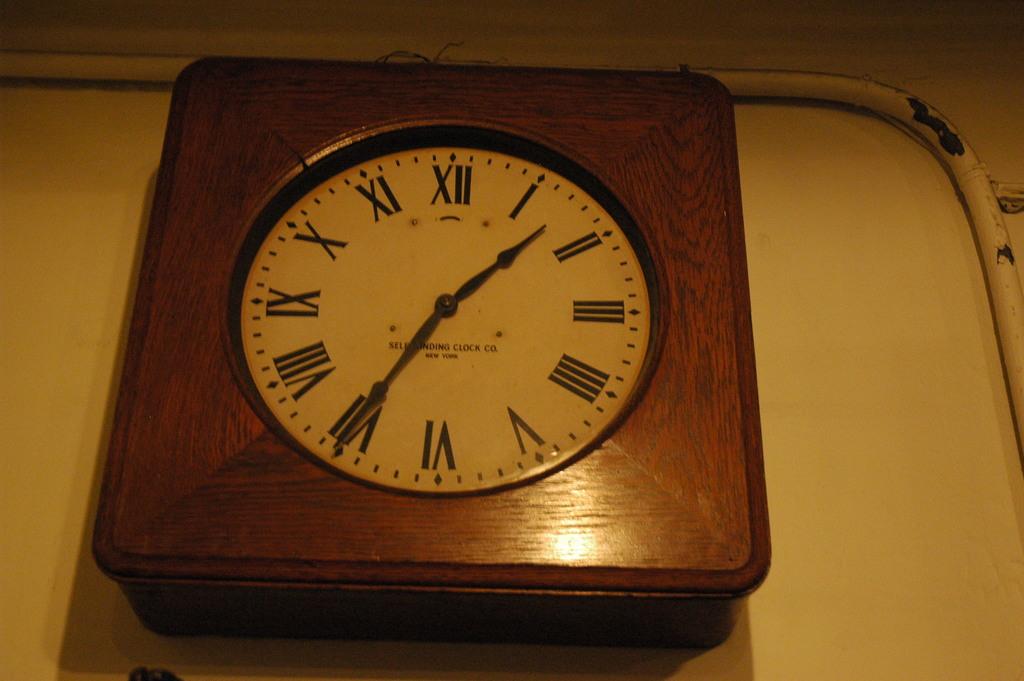Where is the minute hand pointing?
Your response must be concise. Vii. 